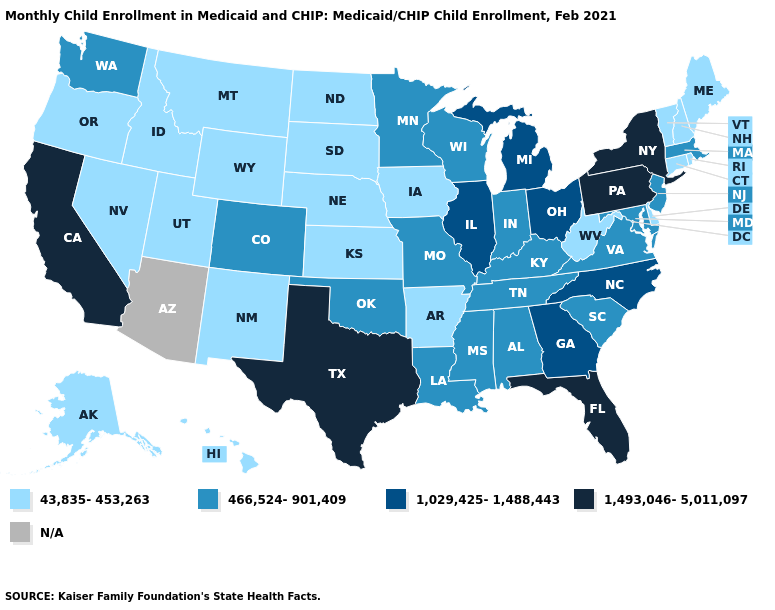Name the states that have a value in the range 1,493,046-5,011,097?
Short answer required. California, Florida, New York, Pennsylvania, Texas. Name the states that have a value in the range 1,493,046-5,011,097?
Concise answer only. California, Florida, New York, Pennsylvania, Texas. What is the highest value in the USA?
Keep it brief. 1,493,046-5,011,097. What is the value of Missouri?
Keep it brief. 466,524-901,409. Among the states that border Massachusetts , which have the lowest value?
Short answer required. Connecticut, New Hampshire, Rhode Island, Vermont. What is the value of North Dakota?
Quick response, please. 43,835-453,263. Name the states that have a value in the range 43,835-453,263?
Write a very short answer. Alaska, Arkansas, Connecticut, Delaware, Hawaii, Idaho, Iowa, Kansas, Maine, Montana, Nebraska, Nevada, New Hampshire, New Mexico, North Dakota, Oregon, Rhode Island, South Dakota, Utah, Vermont, West Virginia, Wyoming. Among the states that border Texas , does Arkansas have the lowest value?
Answer briefly. Yes. Which states have the lowest value in the USA?
Be succinct. Alaska, Arkansas, Connecticut, Delaware, Hawaii, Idaho, Iowa, Kansas, Maine, Montana, Nebraska, Nevada, New Hampshire, New Mexico, North Dakota, Oregon, Rhode Island, South Dakota, Utah, Vermont, West Virginia, Wyoming. What is the highest value in states that border Virginia?
Be succinct. 1,029,425-1,488,443. What is the highest value in states that border Illinois?
Concise answer only. 466,524-901,409. What is the highest value in states that border New Hampshire?
Write a very short answer. 466,524-901,409. 